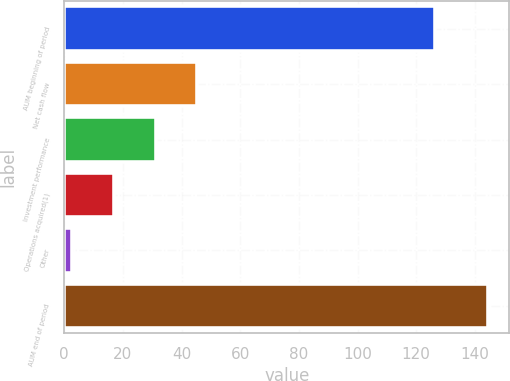Convert chart to OTSL. <chart><loc_0><loc_0><loc_500><loc_500><bar_chart><fcel>AUM beginning of period<fcel>Net cash flow<fcel>Investment performance<fcel>Operations acquired(1)<fcel>Other<fcel>AUM end of period<nl><fcel>126.4<fcel>45.31<fcel>31.14<fcel>16.97<fcel>2.8<fcel>144.5<nl></chart> 